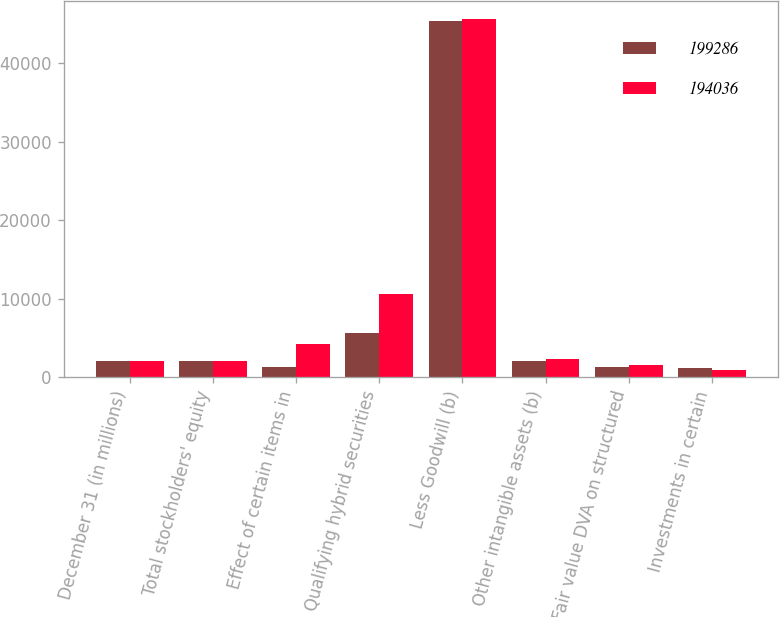<chart> <loc_0><loc_0><loc_500><loc_500><stacked_bar_chart><ecel><fcel>December 31 (in millions)<fcel>Total stockholders' equity<fcel>Effect of certain items in<fcel>Qualifying hybrid securities<fcel>Less Goodwill (b)<fcel>Other intangible assets (b)<fcel>Fair value DVA on structured<fcel>Investments in certain<nl><fcel>199286<fcel>2013<fcel>2012.5<fcel>1337<fcel>5618<fcel>45320<fcel>2012<fcel>1300<fcel>1164<nl><fcel>194036<fcel>2012<fcel>2012.5<fcel>4198<fcel>10608<fcel>45663<fcel>2311<fcel>1577<fcel>926<nl></chart> 